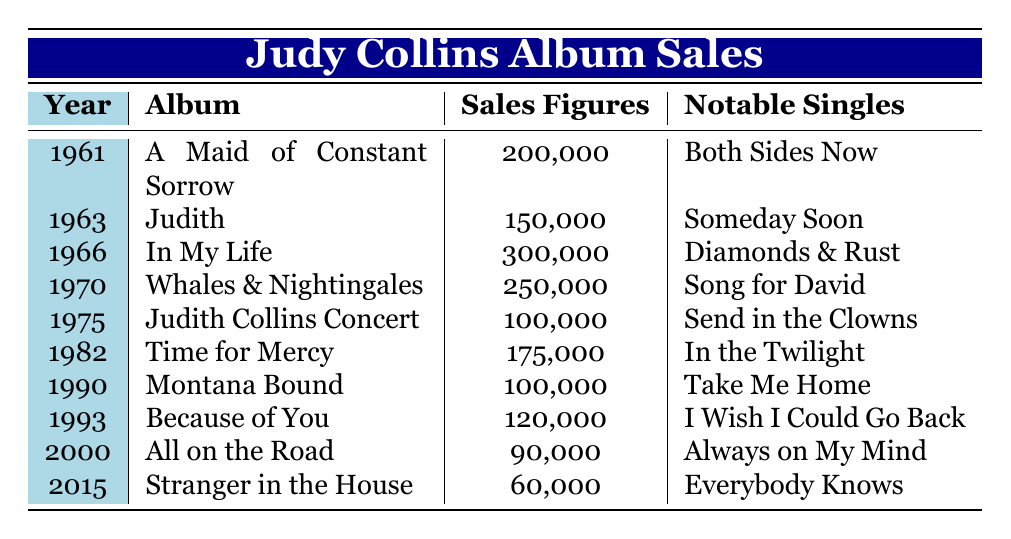What was the highest selling album by Judy Collins? From the table, I can see that "In My Life" released in 1966 has the highest sales figure of 300,000 units.
Answer: In My Life Which year did Judy Collins release the album "Judith"? The table indicates that "Judith" was released in 1963.
Answer: 1963 What is the total sales figure of all Judy Collins albums listed in the table? I need to sum up the sales figures: 200000 + 150000 + 300000 + 250000 + 100000 + 175000 + 100000 + 120000 + 90000 + 60000 = 1,485,000.
Answer: 1,485,000 Did Judy Collins release an album that sold more than 250,000 units? Yes, according to the table, "In My Life" (300,000 units) and "Whales & Nightingales" (250,000 units) both sold more than 250,000.
Answer: Yes What is the average sales figure of Judy Collins albums from the years 1961 to 1982? The relevant albums are "A Maid of Constant Sorrow," "Judith," "In My Life," "Whales & Nightingales," and "Time for Mercy." Their sales figures are 200000, 150000, 300000, 250000, and 175000. The total is 1,075,000, and with 5 albums, the average is 1,075,000 / 5 = 215,000.
Answer: 215,000 What was the lowest sales figure and which album corresponds to it? The lowest sales figure in the table is 60,000, associated with the album "Stranger in the House" released in 2015.
Answer: Stranger in the House How many albums did Judy Collins sell over 100,000 units? Looking at the sales figures, the albums that sold over 100,000 units are: "A Maid of Constant Sorrow," "Judith," "In My Life," "Whales & Nightingales," "Time for Mercy," and "Because of You." This totals 6 albums.
Answer: 6 Was "Send in the Clowns" a notable single from an album that sold less than 200,000 units? Yes, "Send in the Clowns" is from the album "Judith Collins Concert," which sold 100,000 units, less than 200,000.
Answer: Yes What is the difference in sales figures between the best-selling and the worst-selling album? The best-selling album is "In My Life" with 300,000 units, and the worst-selling is "Stranger in the House" with 60,000 units. The difference is 300,000 - 60,000 = 240,000.
Answer: 240,000 Which album was released last and what were its sales figures? The last album released according to the table is "Stranger in the House," which had sales figures of 60,000.
Answer: Stranger in the House, 60,000 